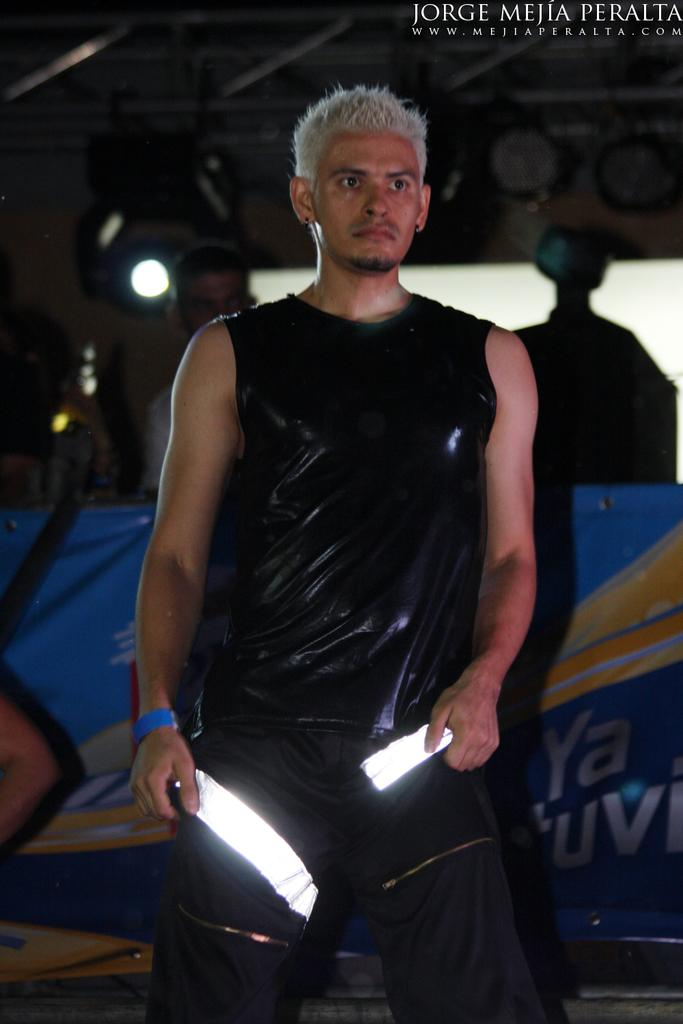<image>
Describe the image concisely. a man is standing and behind him are the letters YA 